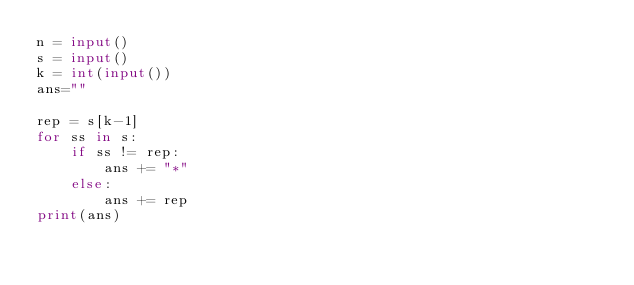Convert code to text. <code><loc_0><loc_0><loc_500><loc_500><_Python_>n = input()
s = input()
k = int(input())
ans=""

rep = s[k-1]
for ss in s:
    if ss != rep:
        ans += "*"
    else:
        ans += rep
print(ans)</code> 